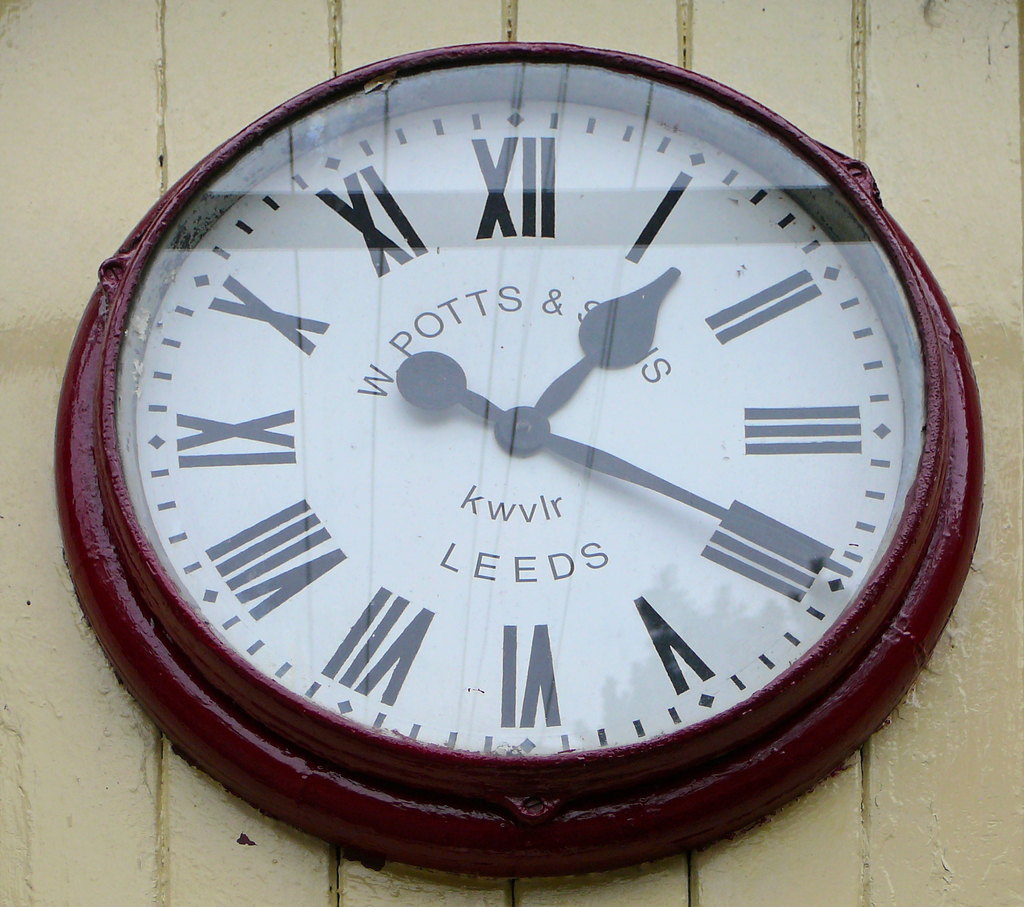Provide a one-sentence caption for the provided image. An antique circular clock by A. W. Potts & Sons, featuring Roman numerals and the maker's mark, mounted on a cream-colored background in Leeds, IA, showing signs of weathering and the passage of time. 